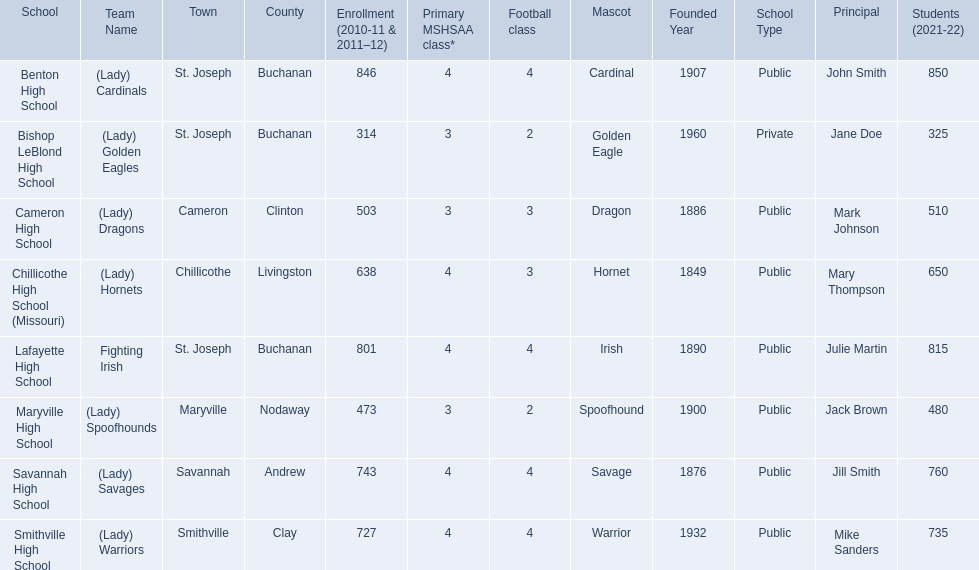What are the three schools in the town of st. joseph? St. Joseph, St. Joseph, St. Joseph. Of the three schools in st. joseph which school's team name does not depict a type of animal? Lafayette High School. 